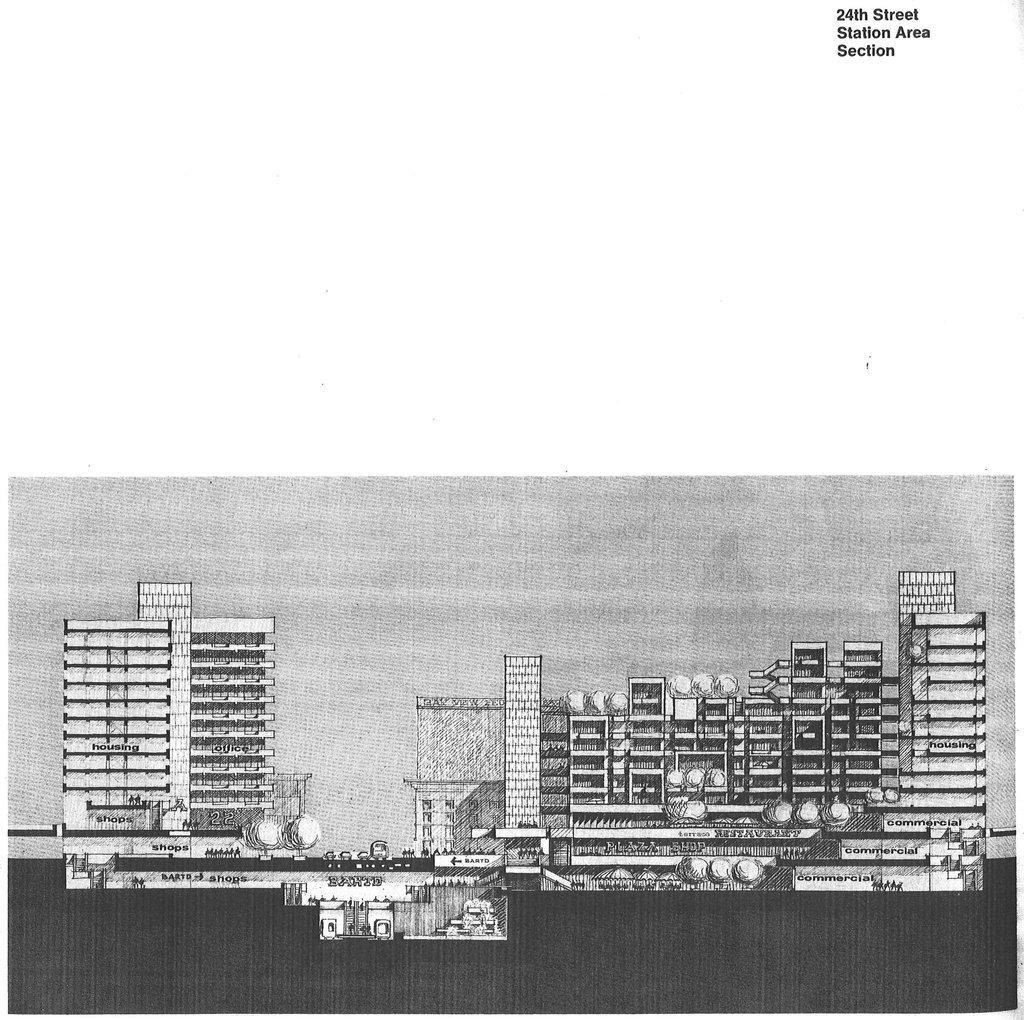How would you summarize this image in a sentence or two? This is a black and white image. In this image we can see the picture of buildings. 